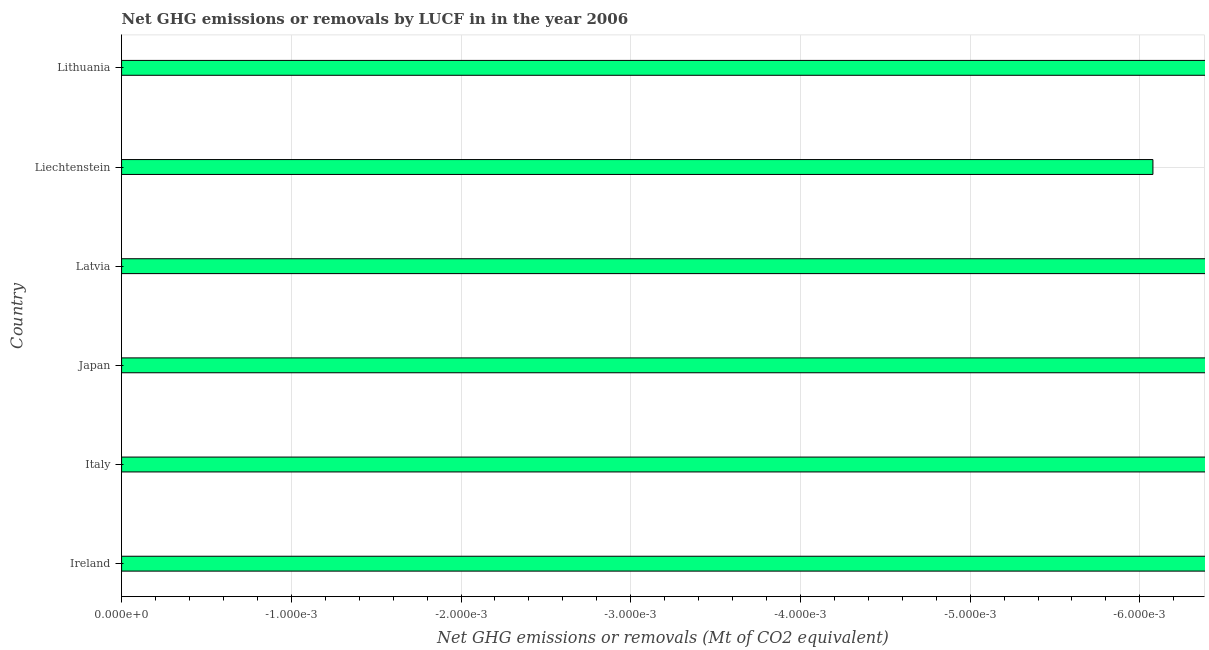What is the title of the graph?
Provide a succinct answer. Net GHG emissions or removals by LUCF in in the year 2006. What is the label or title of the X-axis?
Keep it short and to the point. Net GHG emissions or removals (Mt of CO2 equivalent). What is the label or title of the Y-axis?
Keep it short and to the point. Country. What is the ghg net emissions or removals in Liechtenstein?
Keep it short and to the point. 0. Across all countries, what is the minimum ghg net emissions or removals?
Give a very brief answer. 0. What is the median ghg net emissions or removals?
Your response must be concise. 0. In how many countries, is the ghg net emissions or removals greater than -0.002 Mt?
Offer a very short reply. 0. In how many countries, is the ghg net emissions or removals greater than the average ghg net emissions or removals taken over all countries?
Provide a succinct answer. 0. How many bars are there?
Your answer should be very brief. 0. How many countries are there in the graph?
Offer a very short reply. 6. What is the difference between two consecutive major ticks on the X-axis?
Make the answer very short. 0. Are the values on the major ticks of X-axis written in scientific E-notation?
Keep it short and to the point. Yes. What is the Net GHG emissions or removals (Mt of CO2 equivalent) of Italy?
Provide a short and direct response. 0. What is the Net GHG emissions or removals (Mt of CO2 equivalent) of Lithuania?
Make the answer very short. 0. 